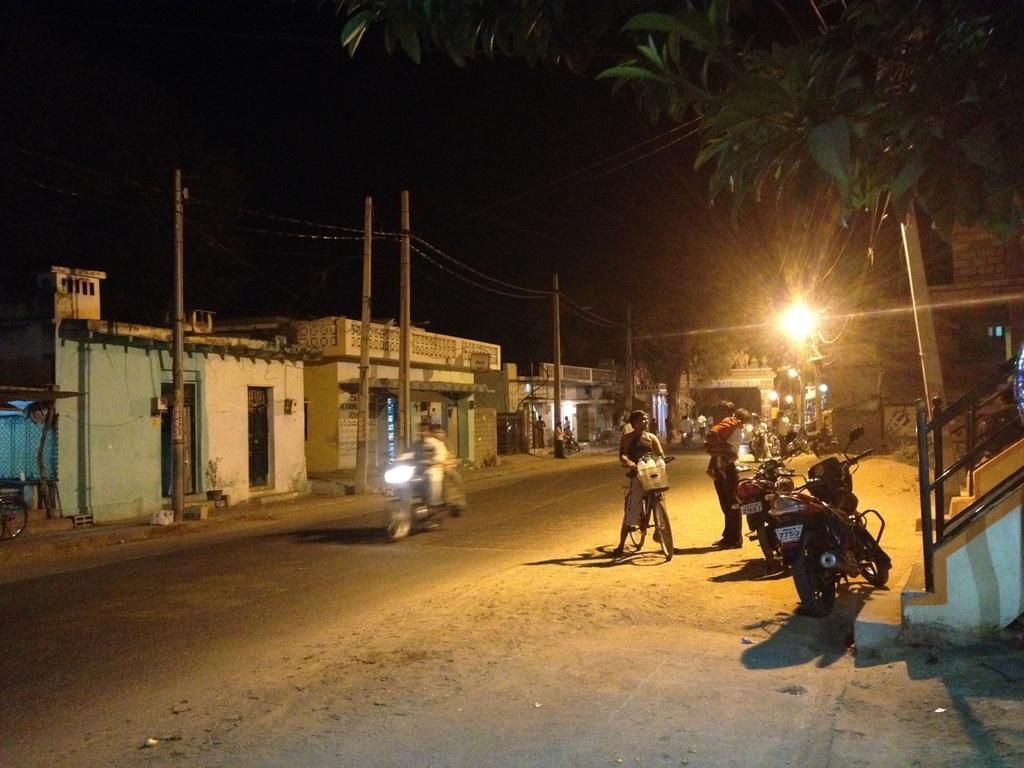Could you give a brief overview of what you see in this image? In the foreground of the picture I can see the road and there are vehicles on the road. I can see a man on the bicycle having a conversation with a man standing on the side of the road on the right side. I can see the motorcycles parked on the side of the road. There are houses on the side of the road on the left side. I can see the electric poles on the side of the road. I can see the green leaves on the top right side of the picture. 